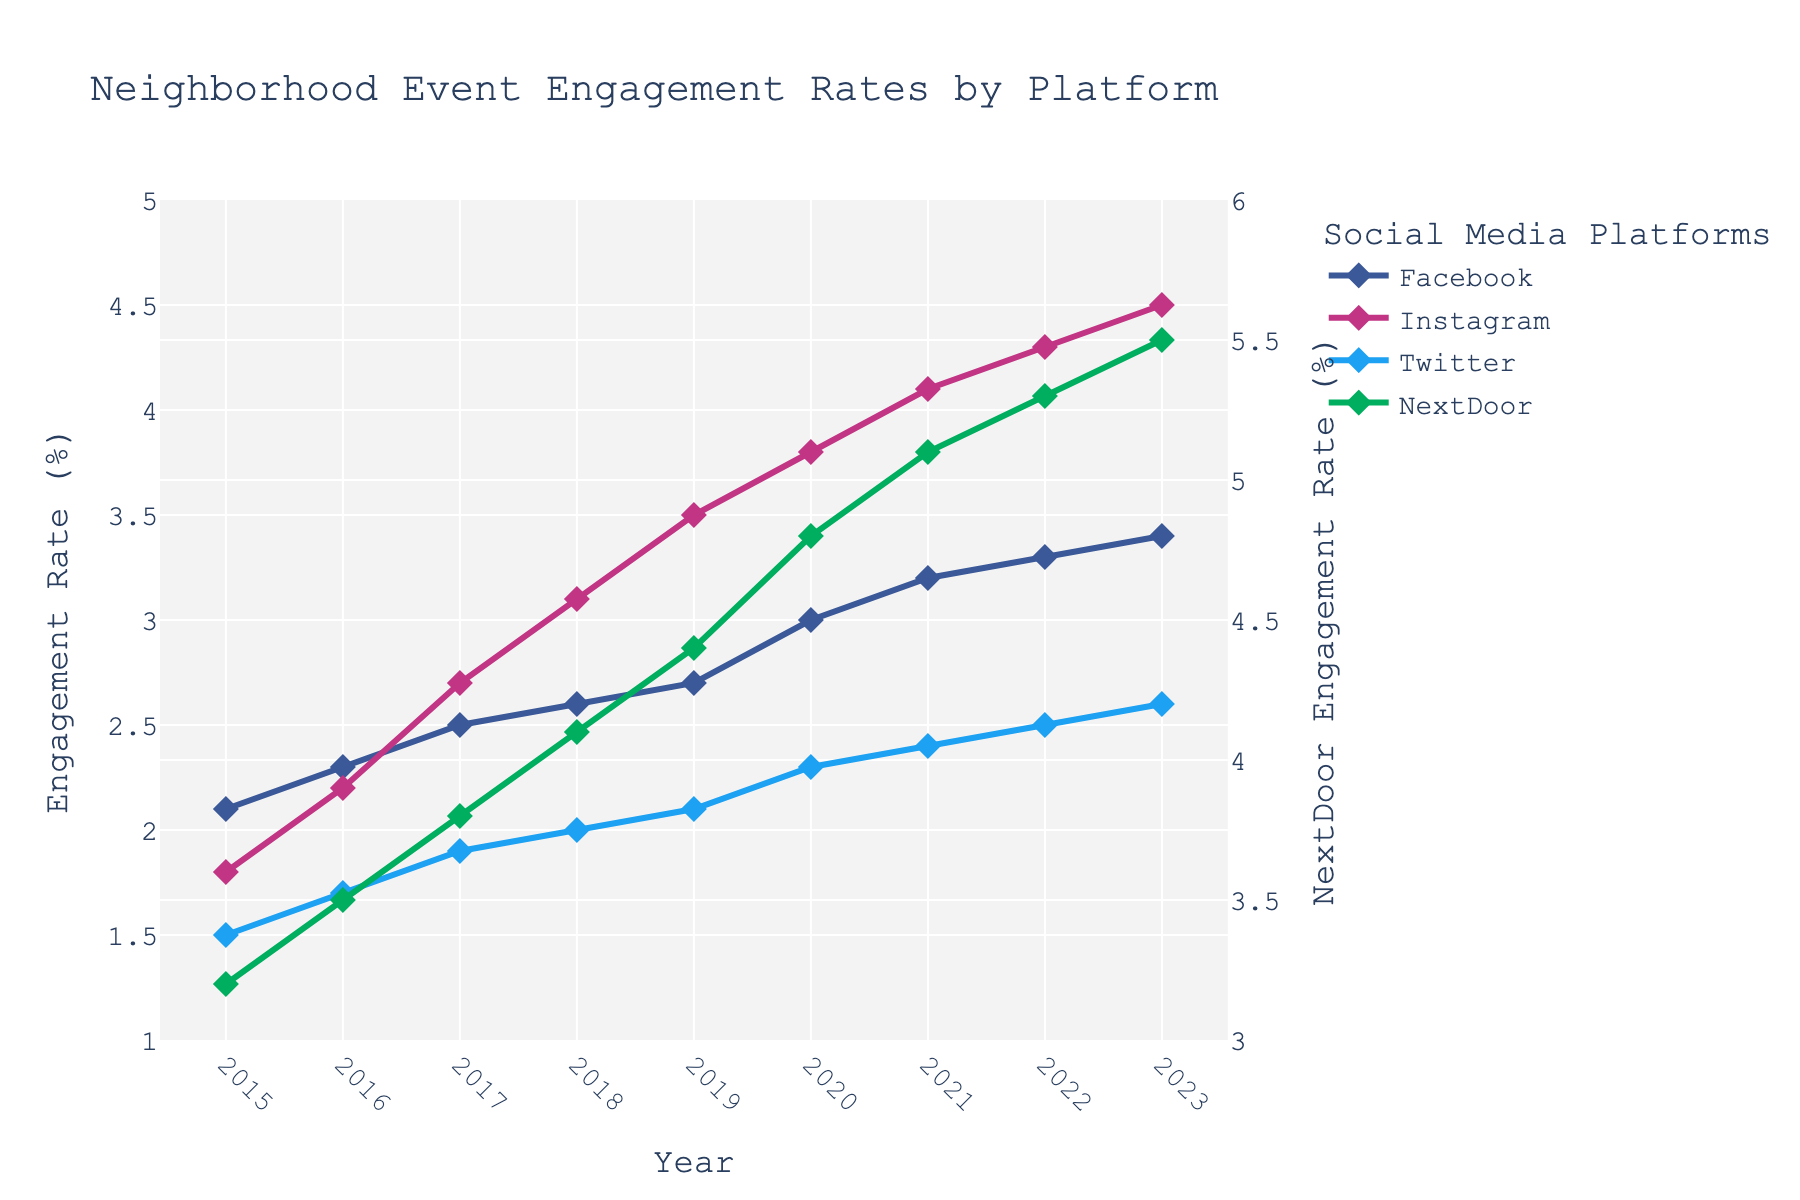Which social media platform had the highest engagement rate in 2023? Look at the y-values for each platform in the year 2023. The highest y-value represents the platform with the highest engagement rate.
Answer: NextDoor How did Facebook engagement change from 2015 to 2023? Subtract the Facebook engagement rate in 2015 (2.1%) from the rate in 2023 (3.4%) to determine the change.
Answer: Increased by 1.3% What is the average engagement rate for Instagram from 2015 to 2023? Add the engagement rates for Instagram from each year and divide by the number of years (9). Calculate: (1.8 + 2.2 + 2.7 + 3.1 + 3.5 + 3.8 + 4.1 + 4.3 + 4.5)/9 = 3.33%.
Answer: 3.33% Which year did Twitter see the largest increase in engagement rate compared to the previous year? Compare the year-over-year differences in Twitter engagement rates. The largest increase is between 2019 and 2020, increasing from 2.1% to 2.3%.
Answer: 2020 Between Instagram and Facebook, which platform had a smaller increase in engagement rate from 2015 to 2023? Calculate the increase for both platforms: Instagram increased from 1.8% to 4.5% (2.7% increase), and Facebook increased from 2.1% to 3.4% (1.3% increase).
Answer: Facebook If you average the engagement rates of all platforms in 2020, what value do you get? Sum the engagement rates for all platforms in 2020 and divide by the number of platforms (4): (3.0 + 3.8 + 2.3 + 4.8)/4 = 3.475%.
Answer: 3.475% Which platform had a consistent year-on-year increase in engagement rate for every year from 2015 to 2023? Compare the engagement rate each year for each platform, looking for a consistent increase every year. NextDoor has this consistent increase.
Answer: NextDoor What is the total increase in engagement rate for NextDoor from 2015 to 2023? Subtract the engagement rate of NextDoor in 2015 (3.2%) from the rate in 2023 (5.5%) to find the total increase.
Answer: 2.3% In which year was the engagement rate for Facebook equal to the current (2023) engagement rate for Twitter? Look for the year where Facebook's engagement rate matches Twitter's 2023 rate of 2.6%. This occurs in 2021.
Answer: 2021 